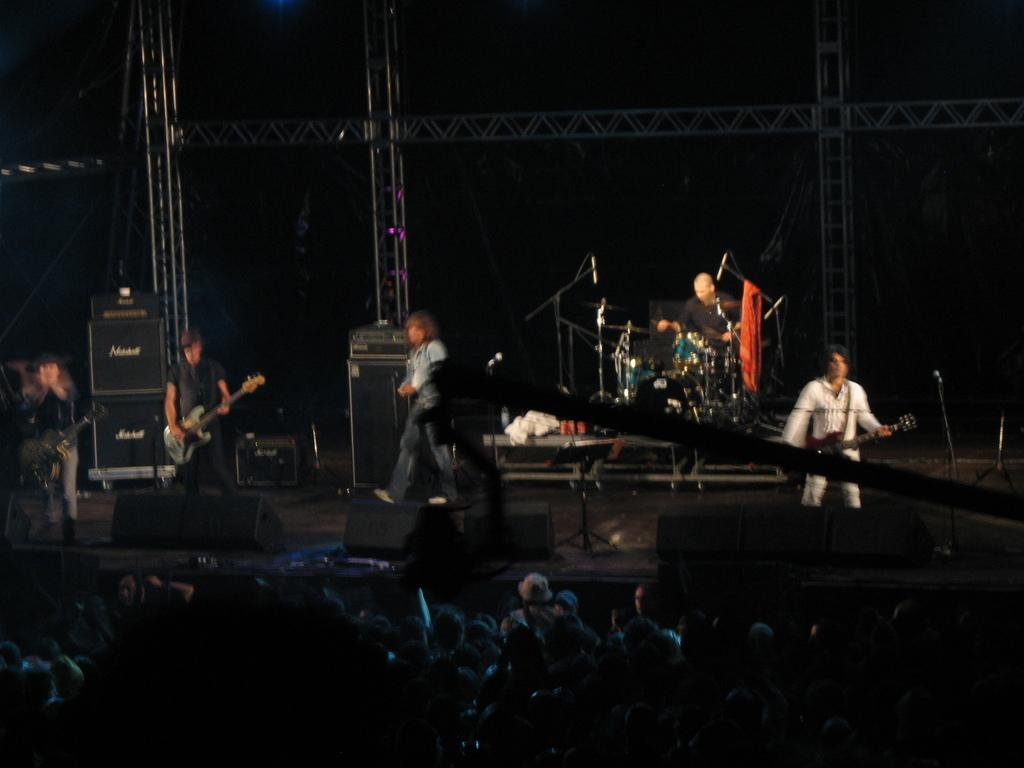What are the persons on stage doing? The persons on stage are playing musical instruments. How many audience members are present in front of the stage? There are many audience members in front of the stage. What are the audience members doing? The audience members are standing and staring at the stage. How many beds can be seen in the image? There are no beds present in the image. Can you compare the size of the musical instruments to the size of the audience members? We cannot compare the size of the musical instruments to the size of the audience members, as the image does not provide any information about the dimensions of these objects. 